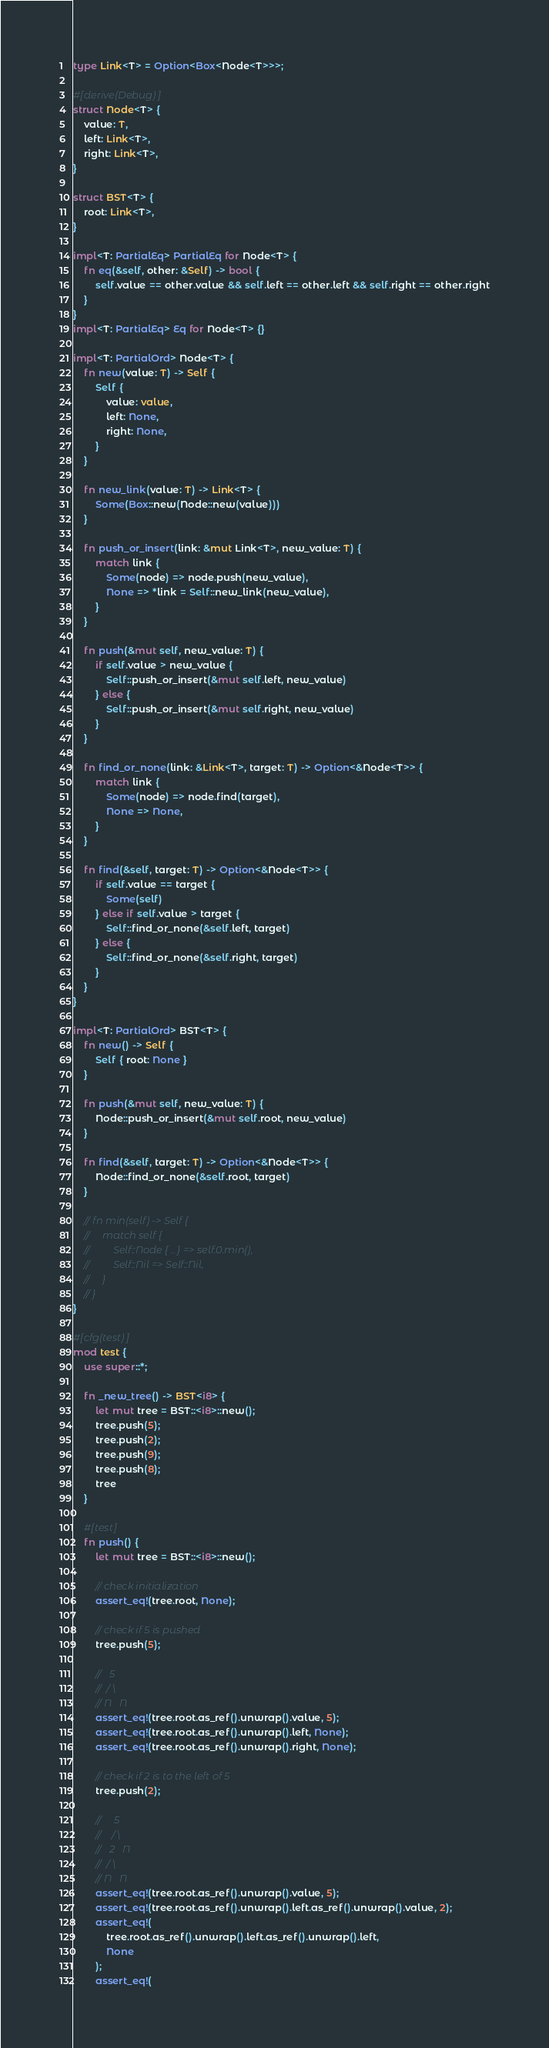<code> <loc_0><loc_0><loc_500><loc_500><_Rust_>type Link<T> = Option<Box<Node<T>>>;

#[derive(Debug)]
struct Node<T> {
    value: T,
    left: Link<T>,
    right: Link<T>,
}

struct BST<T> {
    root: Link<T>,
}

impl<T: PartialEq> PartialEq for Node<T> {
    fn eq(&self, other: &Self) -> bool {
        self.value == other.value && self.left == other.left && self.right == other.right
    }
}
impl<T: PartialEq> Eq for Node<T> {}

impl<T: PartialOrd> Node<T> {
    fn new(value: T) -> Self {
        Self {
            value: value,
            left: None,
            right: None,
        }
    }

    fn new_link(value: T) -> Link<T> {
        Some(Box::new(Node::new(value)))
    }

    fn push_or_insert(link: &mut Link<T>, new_value: T) {
        match link {
            Some(node) => node.push(new_value),
            None => *link = Self::new_link(new_value),
        }
    }

    fn push(&mut self, new_value: T) {
        if self.value > new_value {
            Self::push_or_insert(&mut self.left, new_value)
        } else {
            Self::push_or_insert(&mut self.right, new_value)
        }
    }

    fn find_or_none(link: &Link<T>, target: T) -> Option<&Node<T>> {
        match link {
            Some(node) => node.find(target),
            None => None,
        }
    }

    fn find(&self, target: T) -> Option<&Node<T>> {
        if self.value == target {
            Some(self)
        } else if self.value > target {
            Self::find_or_none(&self.left, target)
        } else {
            Self::find_or_none(&self.right, target)
        }
    }
}

impl<T: PartialOrd> BST<T> {
    fn new() -> Self {
        Self { root: None }
    }

    fn push(&mut self, new_value: T) {
        Node::push_or_insert(&mut self.root, new_value)
    }

    fn find(&self, target: T) -> Option<&Node<T>> {
        Node::find_or_none(&self.root, target)
    }

    // fn min(self) -> Self {
    //     match self {
    //         Self::Node { .. } => self.0.min(),
    //         Self::Nil => Self::Nil,
    //     }
    // }
}

#[cfg(test)]
mod test {
    use super::*;

    fn _new_tree() -> BST<i8> {
        let mut tree = BST::<i8>::new();
        tree.push(5);
        tree.push(2);
        tree.push(9);
        tree.push(8);
        tree
    }

    #[test]
    fn push() {
        let mut tree = BST::<i8>::new();

        // check initialization
        assert_eq!(tree.root, None);

        // check if 5 is pushed
        tree.push(5);

        //   5
        //  / \
        // N   N
        assert_eq!(tree.root.as_ref().unwrap().value, 5);
        assert_eq!(tree.root.as_ref().unwrap().left, None);
        assert_eq!(tree.root.as_ref().unwrap().right, None);

        // check if 2 is to the left of 5
        tree.push(2);

        //     5
        //    / \
        //   2   N
        //  / \
        // N   N
        assert_eq!(tree.root.as_ref().unwrap().value, 5);
        assert_eq!(tree.root.as_ref().unwrap().left.as_ref().unwrap().value, 2);
        assert_eq!(
            tree.root.as_ref().unwrap().left.as_ref().unwrap().left,
            None
        );
        assert_eq!(</code> 